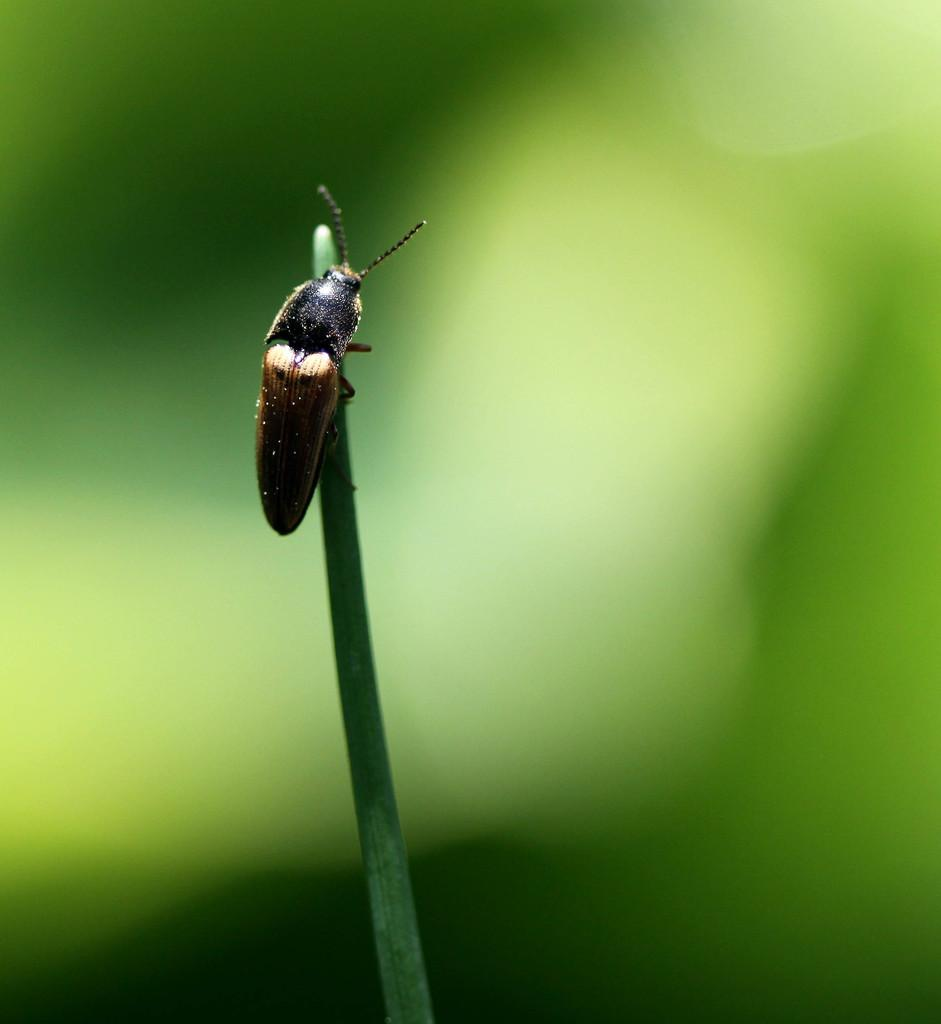What is present on the plant in the image? There is an insect on the plant in the image. What color is predominant in the background of the image? The background of the image is predominantly green. Where might this image have been taken? The image may have been taken in a garden, given the presence of a plant and the green background. What type of celery is visible in the image? There is no celery present in the image; it features an insect on a plant. What color is the orange in the image? There is no orange present in the image. 